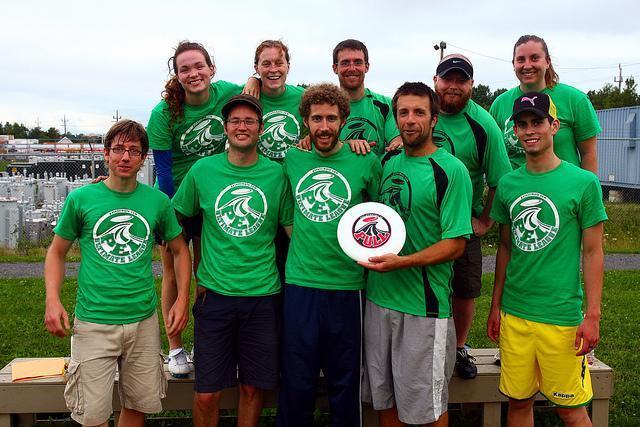How many people are there?
Give a very brief answer. 10. 